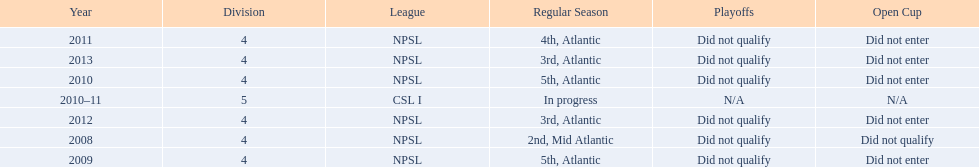What are the names of the leagues? NPSL, CSL I. Which league other than npsl did ny soccer team play under? CSL I. 